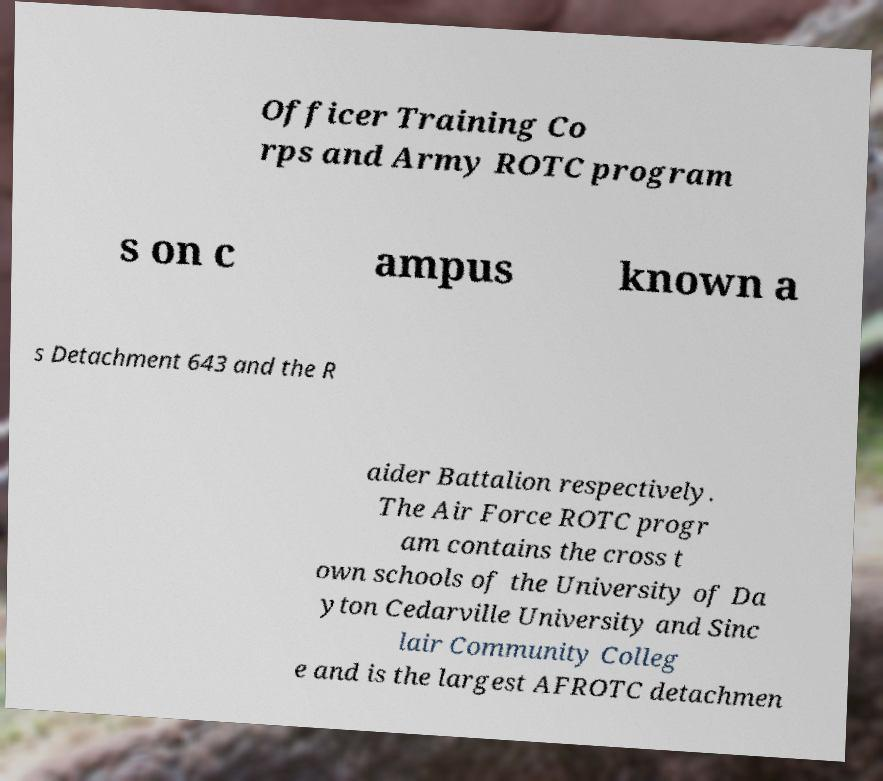I need the written content from this picture converted into text. Can you do that? Officer Training Co rps and Army ROTC program s on c ampus known a s Detachment 643 and the R aider Battalion respectively. The Air Force ROTC progr am contains the cross t own schools of the University of Da yton Cedarville University and Sinc lair Community Colleg e and is the largest AFROTC detachmen 